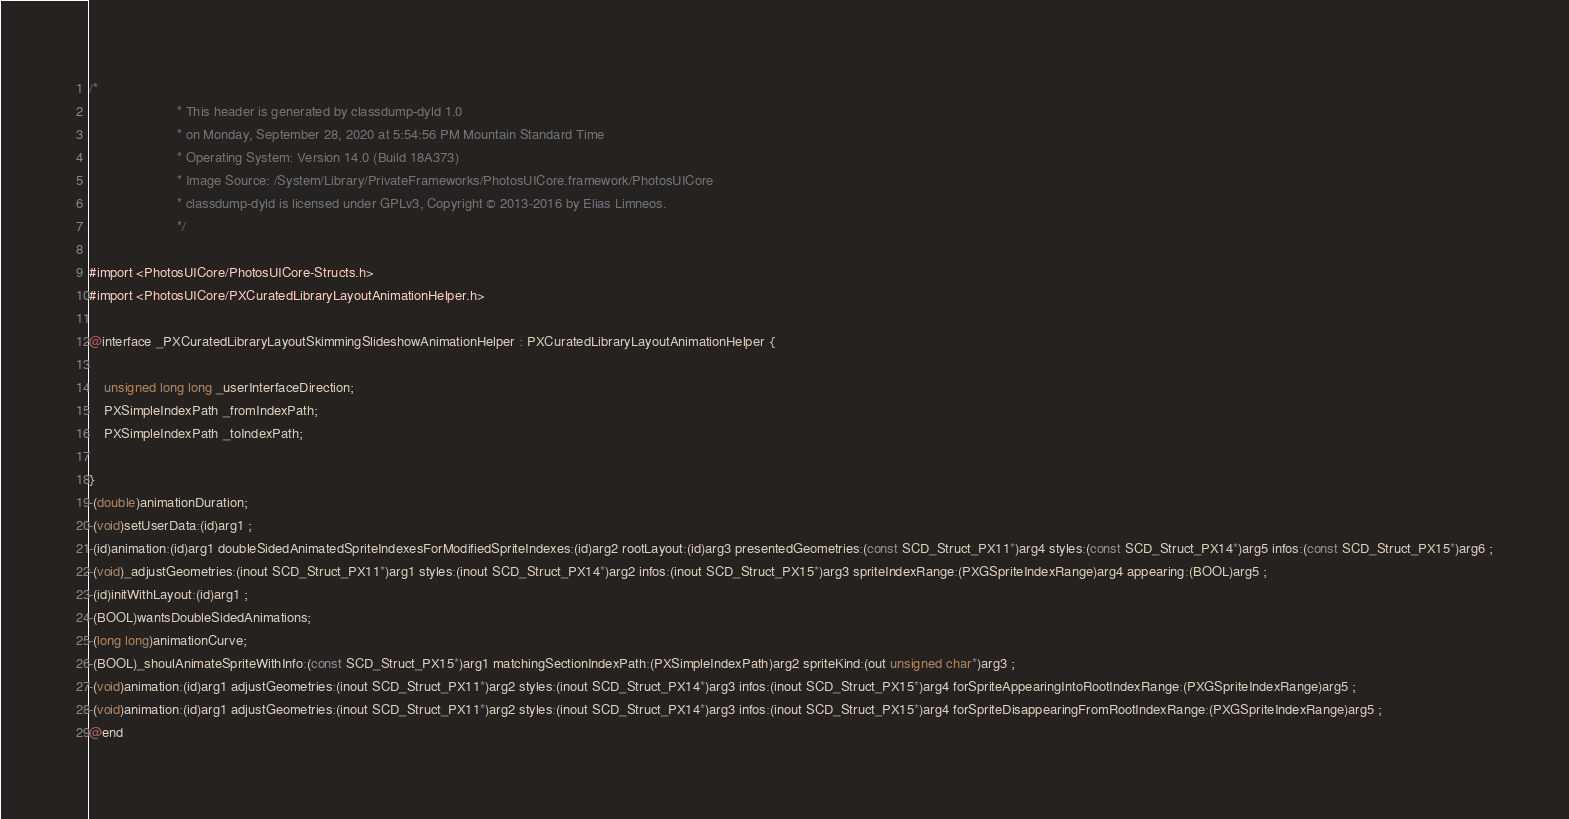<code> <loc_0><loc_0><loc_500><loc_500><_C_>/*
                       * This header is generated by classdump-dyld 1.0
                       * on Monday, September 28, 2020 at 5:54:56 PM Mountain Standard Time
                       * Operating System: Version 14.0 (Build 18A373)
                       * Image Source: /System/Library/PrivateFrameworks/PhotosUICore.framework/PhotosUICore
                       * classdump-dyld is licensed under GPLv3, Copyright © 2013-2016 by Elias Limneos.
                       */

#import <PhotosUICore/PhotosUICore-Structs.h>
#import <PhotosUICore/PXCuratedLibraryLayoutAnimationHelper.h>

@interface _PXCuratedLibraryLayoutSkimmingSlideshowAnimationHelper : PXCuratedLibraryLayoutAnimationHelper {

	unsigned long long _userInterfaceDirection;
	PXSimpleIndexPath _fromIndexPath;
	PXSimpleIndexPath _toIndexPath;

}
-(double)animationDuration;
-(void)setUserData:(id)arg1 ;
-(id)animation:(id)arg1 doubleSidedAnimatedSpriteIndexesForModifiedSpriteIndexes:(id)arg2 rootLayout:(id)arg3 presentedGeometries:(const SCD_Struct_PX11*)arg4 styles:(const SCD_Struct_PX14*)arg5 infos:(const SCD_Struct_PX15*)arg6 ;
-(void)_adjustGeometries:(inout SCD_Struct_PX11*)arg1 styles:(inout SCD_Struct_PX14*)arg2 infos:(inout SCD_Struct_PX15*)arg3 spriteIndexRange:(PXGSpriteIndexRange)arg4 appearing:(BOOL)arg5 ;
-(id)initWithLayout:(id)arg1 ;
-(BOOL)wantsDoubleSidedAnimations;
-(long long)animationCurve;
-(BOOL)_shoulAnimateSpriteWithInfo:(const SCD_Struct_PX15*)arg1 matchingSectionIndexPath:(PXSimpleIndexPath)arg2 spriteKind:(out unsigned char*)arg3 ;
-(void)animation:(id)arg1 adjustGeometries:(inout SCD_Struct_PX11*)arg2 styles:(inout SCD_Struct_PX14*)arg3 infos:(inout SCD_Struct_PX15*)arg4 forSpriteAppearingIntoRootIndexRange:(PXGSpriteIndexRange)arg5 ;
-(void)animation:(id)arg1 adjustGeometries:(inout SCD_Struct_PX11*)arg2 styles:(inout SCD_Struct_PX14*)arg3 infos:(inout SCD_Struct_PX15*)arg4 forSpriteDisappearingFromRootIndexRange:(PXGSpriteIndexRange)arg5 ;
@end

</code> 